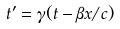Convert formula to latex. <formula><loc_0><loc_0><loc_500><loc_500>t ^ { \prime } = \gamma ( t - \beta x / c )</formula> 